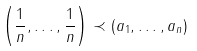Convert formula to latex. <formula><loc_0><loc_0><loc_500><loc_500>\left ( \frac { 1 } { n } , \dots , \frac { 1 } { n } \right ) \prec ( a _ { 1 } , \dots , a _ { n } )</formula> 